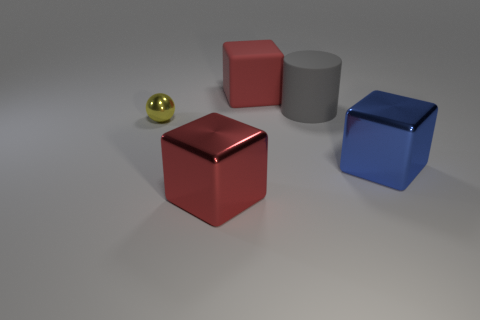There is a big matte object in front of the red block that is behind the red thing in front of the large red rubber cube; what shape is it?
Ensure brevity in your answer.  Cylinder. There is a red cube that is in front of the small yellow object; does it have the same size as the metallic thing right of the big matte cube?
Ensure brevity in your answer.  Yes. What number of red cubes have the same material as the small yellow thing?
Offer a very short reply. 1. What number of cylinders are in front of the metallic thing on the right side of the red block that is in front of the small yellow object?
Your answer should be compact. 0. Do the small yellow object and the red matte object have the same shape?
Provide a short and direct response. No. Is there another large matte thing of the same shape as the gray thing?
Ensure brevity in your answer.  No. What is the shape of the blue object that is the same size as the red matte block?
Give a very brief answer. Cube. What is the red object in front of the block that is right of the large red object behind the gray matte object made of?
Provide a succinct answer. Metal. Do the gray cylinder and the blue metal cube have the same size?
Make the answer very short. Yes. What material is the tiny yellow object?
Your response must be concise. Metal. 